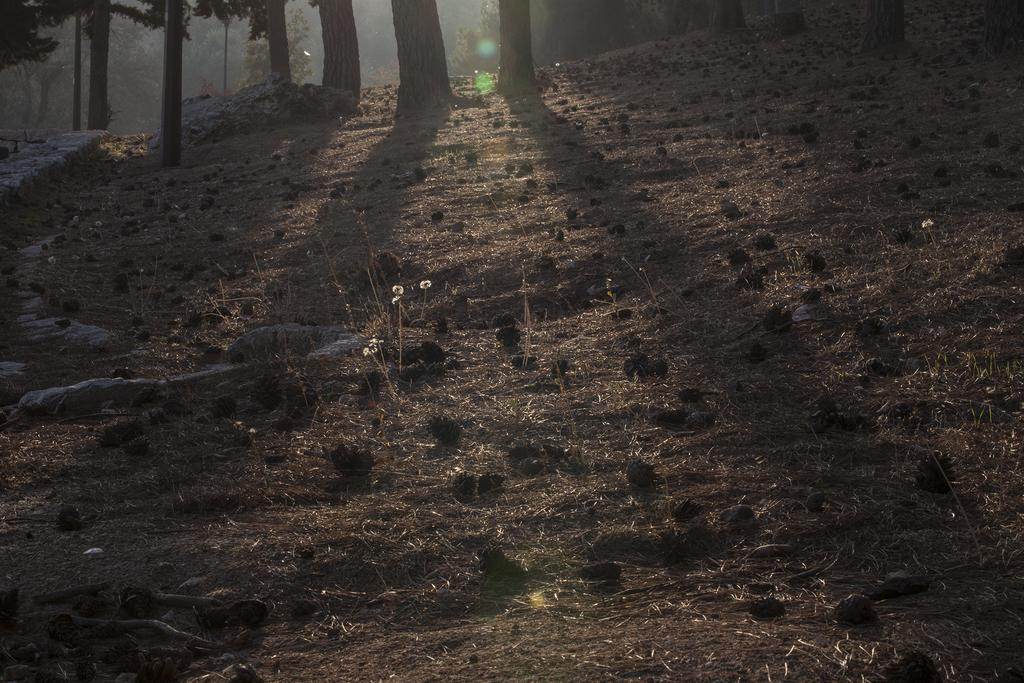What type of surface is visible in the image? There is ground visible in the image. What objects can be seen on the ground in the image? There are stones in the image. What type of vegetation is present in the image? There are trees in the image. What type of horn can be seen on the minister in the image? There is no minister or horn present in the image. How does the hill affect the landscape in the image? There is no hill present in the image; it only features ground, stones, and trees. 